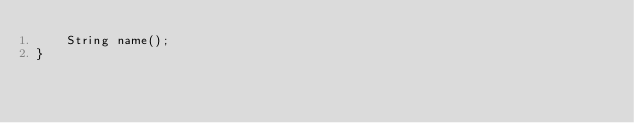<code> <loc_0><loc_0><loc_500><loc_500><_Java_>    String name();
}
</code> 